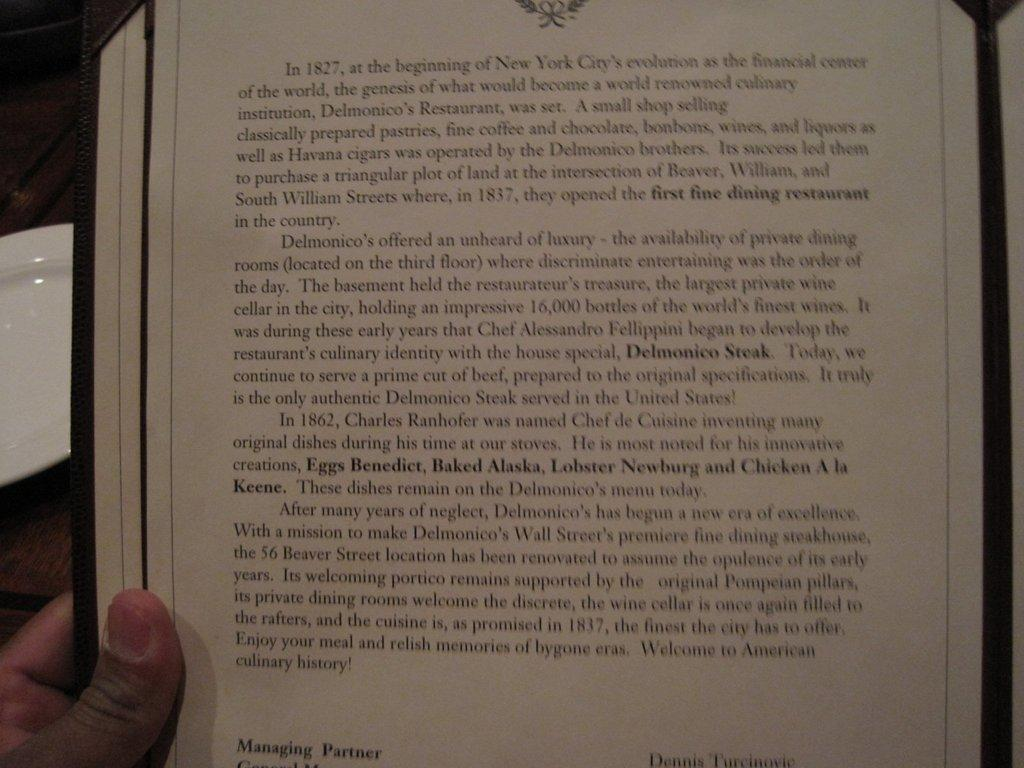<image>
Create a compact narrative representing the image presented. A story begins In 1827, at the begining of New York City's evolution 